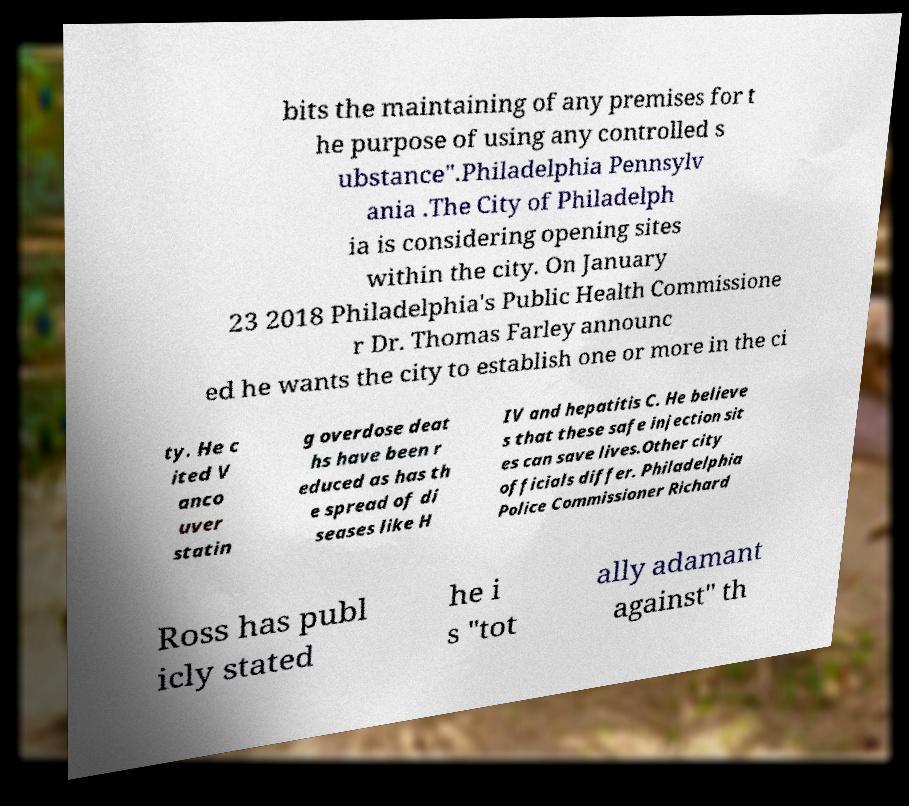Please read and relay the text visible in this image. What does it say? bits the maintaining of any premises for t he purpose of using any controlled s ubstance".Philadelphia Pennsylv ania .The City of Philadelph ia is considering opening sites within the city. On January 23 2018 Philadelphia's Public Health Commissione r Dr. Thomas Farley announc ed he wants the city to establish one or more in the ci ty. He c ited V anco uver statin g overdose deat hs have been r educed as has th e spread of di seases like H IV and hepatitis C. He believe s that these safe injection sit es can save lives.Other city officials differ. Philadelphia Police Commissioner Richard Ross has publ icly stated he i s "tot ally adamant against" th 